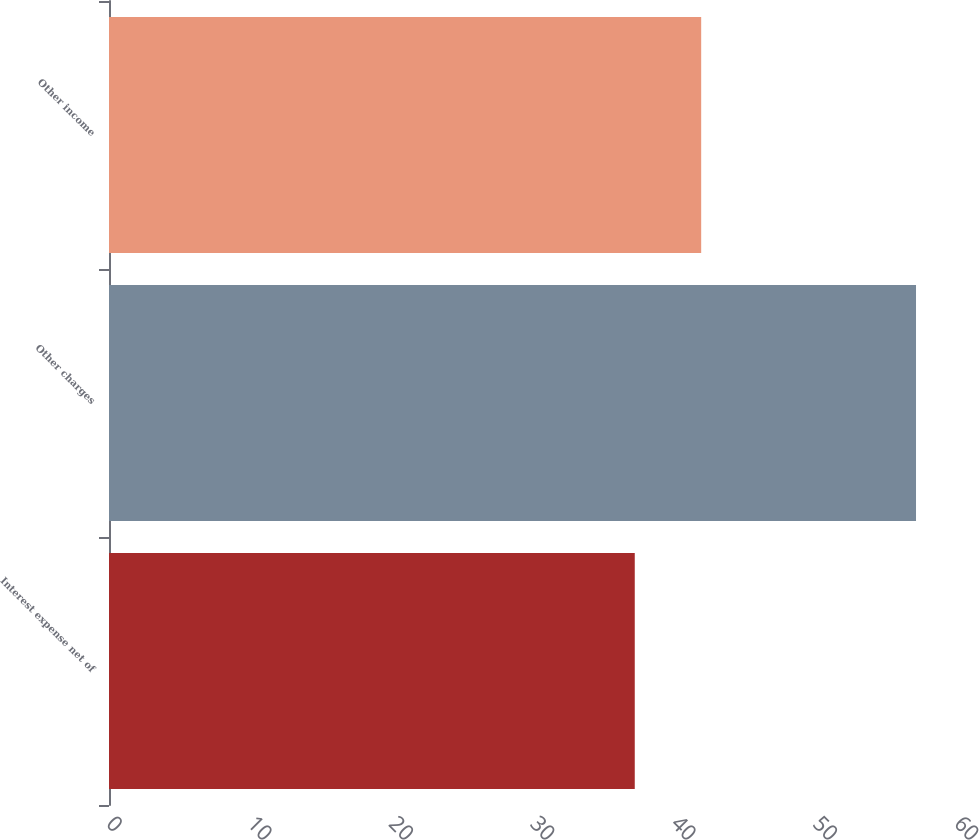Convert chart. <chart><loc_0><loc_0><loc_500><loc_500><bar_chart><fcel>Interest expense net of<fcel>Other charges<fcel>Other income<nl><fcel>37.2<fcel>57.1<fcel>41.9<nl></chart> 